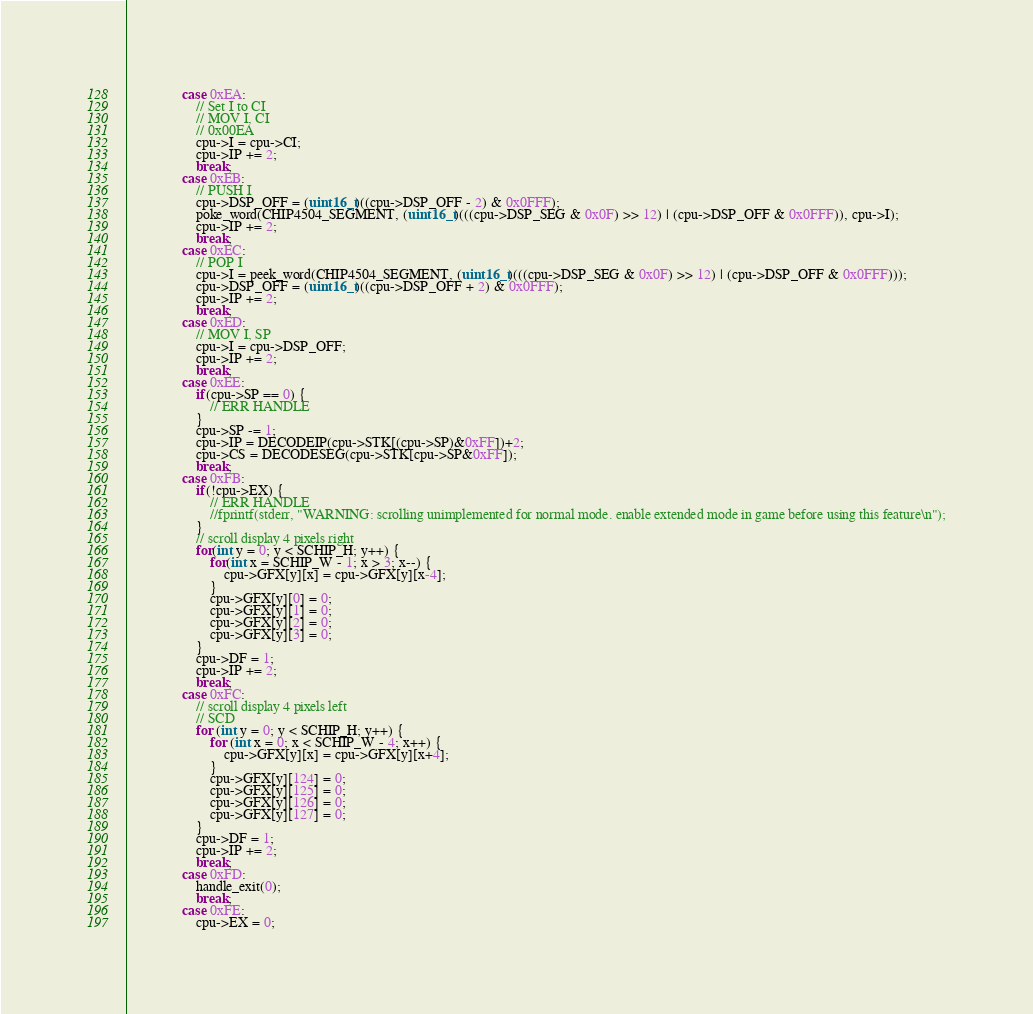<code> <loc_0><loc_0><loc_500><loc_500><_C_>				case 0xEA:
					// Set I to CI
					// MOV I, CI
					// 0x00EA
					cpu->I = cpu->CI;
					cpu->IP += 2;
					break;
				case 0xEB:
					// PUSH I
					cpu->DSP_OFF = (uint16_t)((cpu->DSP_OFF - 2) & 0x0FFF);
					poke_word(CHIP4504_SEGMENT, (uint16_t)(((cpu->DSP_SEG & 0x0F) >> 12) | (cpu->DSP_OFF & 0x0FFF)), cpu->I);
					cpu->IP += 2;
					break;
				case 0xEC:
					// POP I
					cpu->I = peek_word(CHIP4504_SEGMENT, (uint16_t)(((cpu->DSP_SEG & 0x0F) >> 12) | (cpu->DSP_OFF & 0x0FFF)));
					cpu->DSP_OFF = (uint16_t)((cpu->DSP_OFF + 2) & 0x0FFF);
					cpu->IP += 2;
					break;
				case 0xED:
					// MOV I, SP
					cpu->I = cpu->DSP_OFF;
					cpu->IP += 2;
					break;
				case 0xEE:
					if(cpu->SP == 0) {
						// ERR HANDLE
					}
					cpu->SP -= 1;
					cpu->IP = DECODEIP(cpu->STK[(cpu->SP)&0xFF])+2;
					cpu->CS = DECODESEG(cpu->STK[cpu->SP&0xFF]);
					break;
				case 0xFB:
					if(!cpu->EX) {
						// ERR HANDLE
						//fprintf(stderr, "WARNING: scrolling unimplemented for normal mode. enable extended mode in game before using this feature\n");
					}
					// scroll display 4 pixels right
					for(int y = 0; y < SCHIP_H; y++) {
						for(int x = SCHIP_W - 1; x > 3; x--) {
							cpu->GFX[y][x] = cpu->GFX[y][x-4]; 
						}
						cpu->GFX[y][0] = 0;
						cpu->GFX[y][1] = 0;
						cpu->GFX[y][2] = 0;
						cpu->GFX[y][3] = 0;
					}
					cpu->DF = 1;
					cpu->IP += 2;
					break;
				case 0xFC:
					// scroll display 4 pixels left
					// SCD 
					for (int y = 0; y < SCHIP_H; y++) {
						for (int x = 0; x < SCHIP_W - 4; x++) {
							cpu->GFX[y][x] = cpu->GFX[y][x+4];
						}
						cpu->GFX[y][124] = 0;
						cpu->GFX[y][125] = 0;
						cpu->GFX[y][126] = 0;
						cpu->GFX[y][127] = 0;
					}
					cpu->DF = 1;
					cpu->IP += 2;
					break;
				case 0xFD:
					handle_exit(0);
					break;
				case 0xFE:
					cpu->EX = 0;</code> 